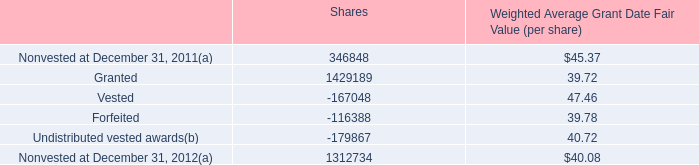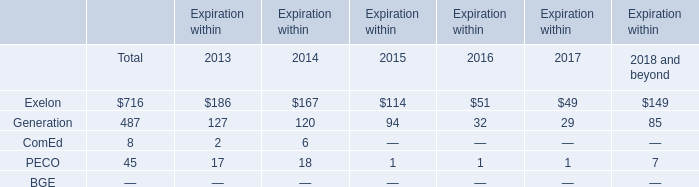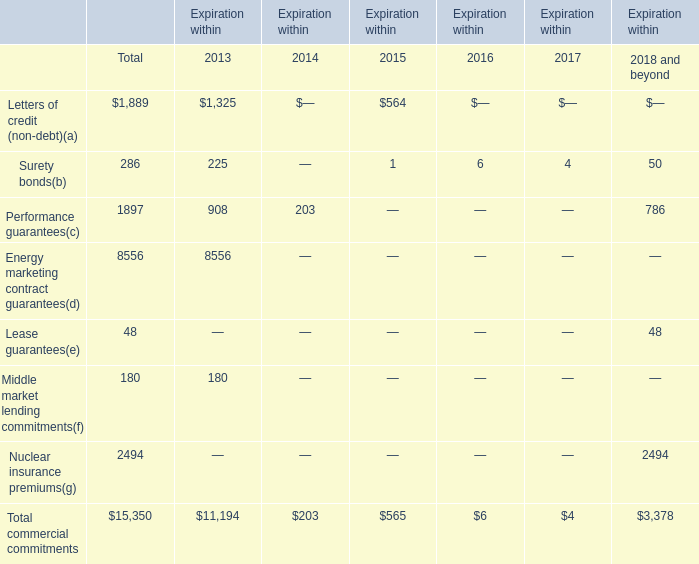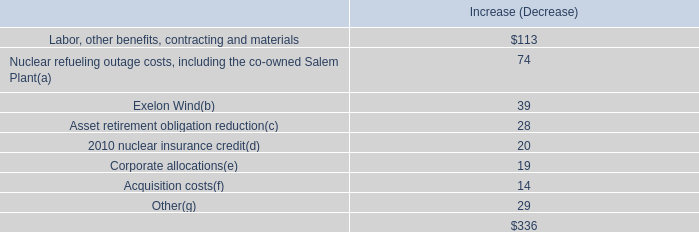What's the difference of Surety bonds between 2016 and 2015? 
Computations: (6 - 1)
Answer: 5.0. 